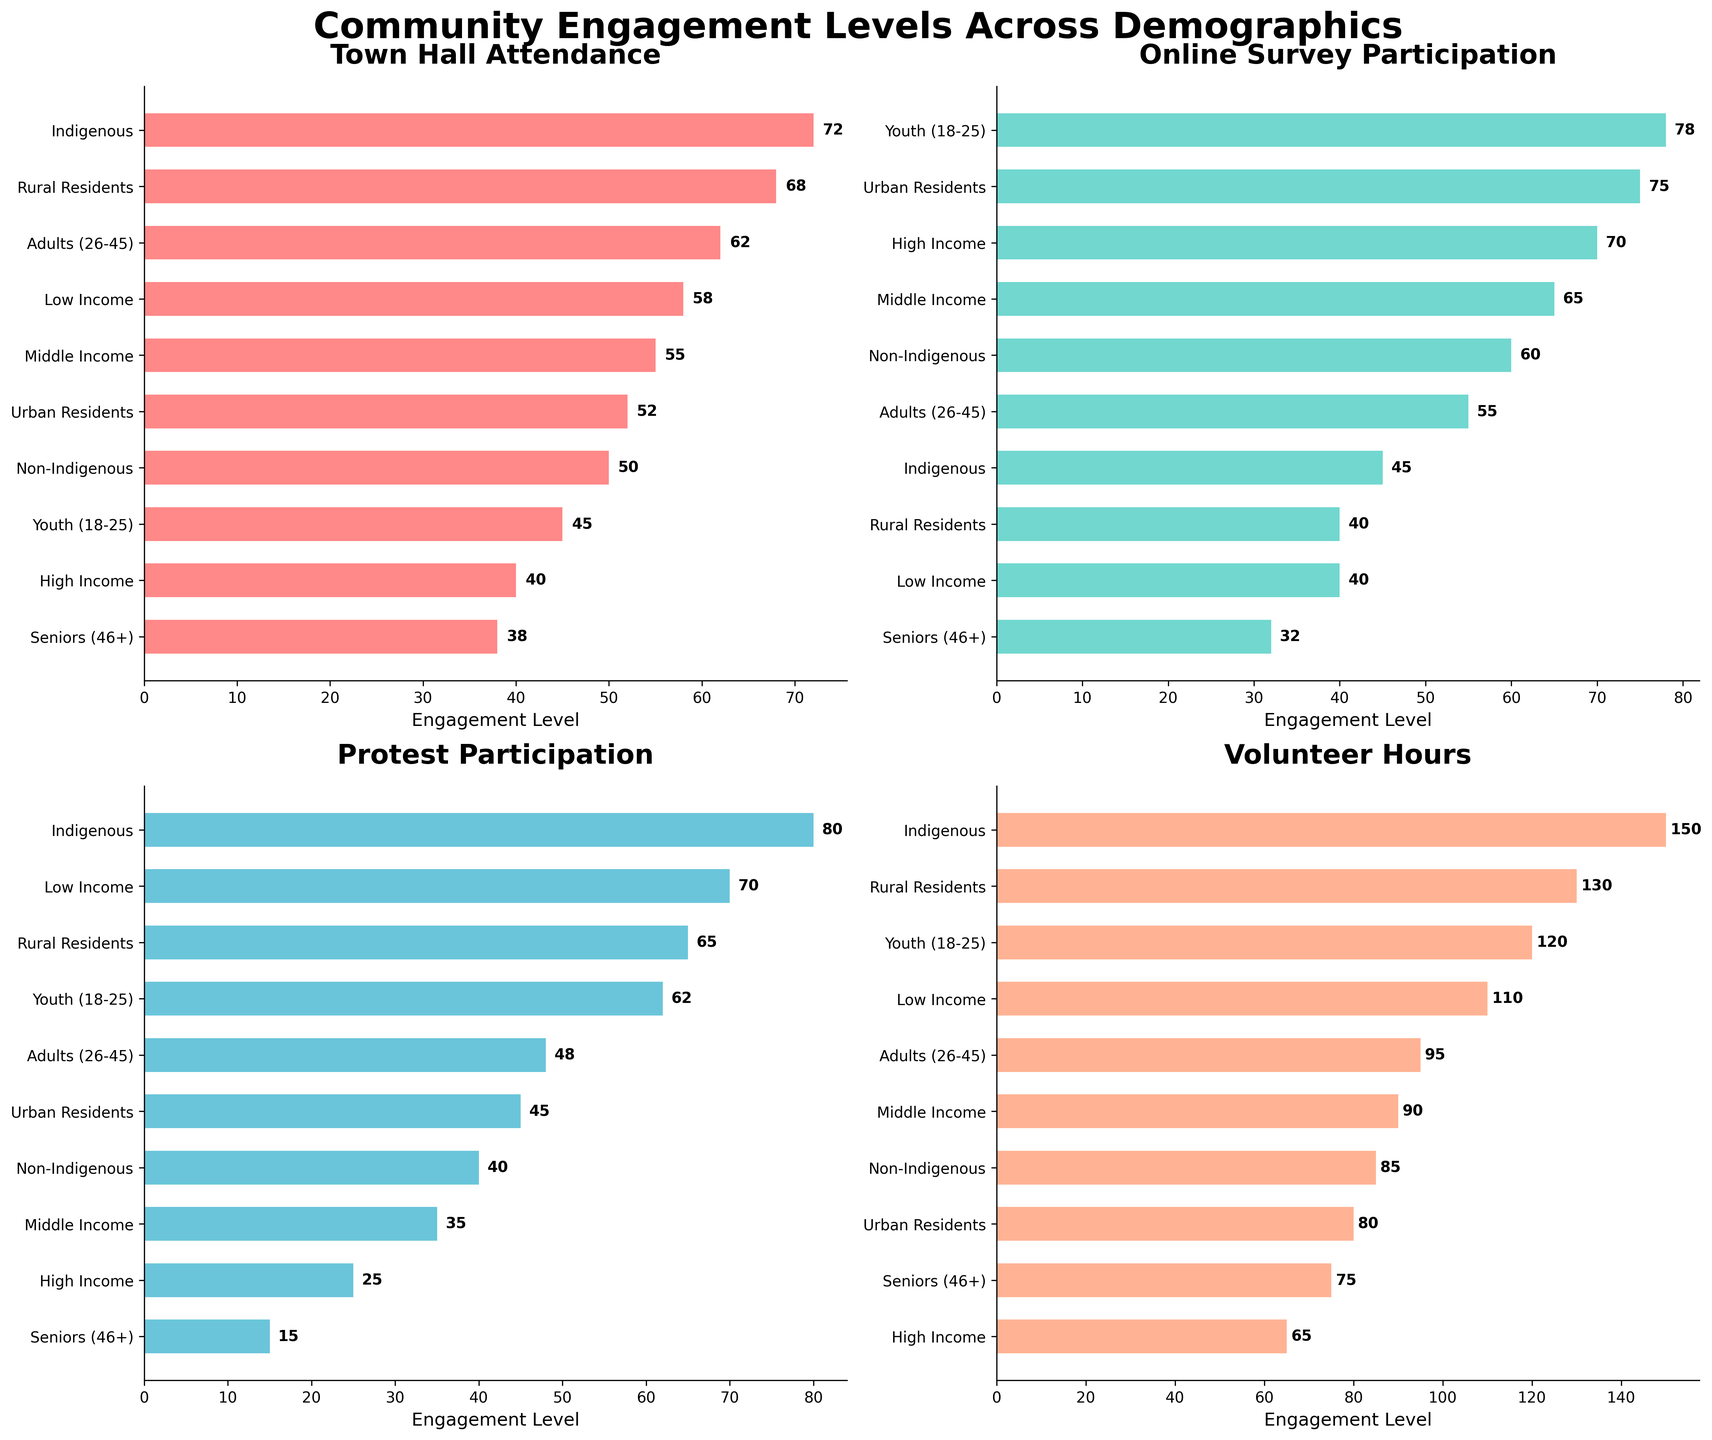What demographic has the highest town hall attendance? Look at the subplot titled "Town Hall Attendance" and identify the top bar. The top bar represents the "Indigenous" demographic with the highest town hall attendance value of 72.
Answer: Indigenous Which demographic participated least in protests? Observe the "Protest Participation" subplot and find the bar with the lowest value. The shortest bar corresponds to the "Seniors (46+)" demographic with a value of 15.
Answer: Seniors (46+) How many different demographics are presented in each subplot? Each subplot represents the same set of demographics. Count the number of bars in any subplot, which should be consistent across all subplots. There are 10 bars representing 10 different demographics.
Answer: 10 What is the average town hall attendance of Urban and Rural residents? Identify the "Town Hall Attendance" values for Urban (52) and Rural (68). Sum the values and divide by 2 to get the average: (52 + 68) / 2 = 60.
Answer: 60 Which demographic volunteers the most hours? Look at the "Volunteer Hours" subplot and identify the top bar. The demographic with the highest value, 150 hours, is "Indigenous".
Answer: Indigenous Compare the Online Survey Participation between Low Income and High Income demographics. Which has higher participation and by how much? Find the "Online Survey Participation" values for Low Income (40) and High Income (70). Subtract the smaller value from the larger value: 70 - 40 = 30. High Income participates more by 30 units.
Answer: High Income by 30 Which demographic has the lowest engagement in online surveys? In the "Online Survey Participation" subplot, identify the shortest bar. The "Seniors (46+)" demographic shows the lowest value at 32.
Answer: Seniors (46+) Between adults (26-45) and seniors (46+), who has higher protest participation and what is the difference? Determine the protest participation values for Adults (48) and Seniors (15). Subtract the smaller value from the larger: 48 - 15 = 33. Adults have higher participation by 33 units.
Answer: Adults by 33 What is the total volunteer hours contributed by Youth and Seniors? Find the volunteer hours values for Youth (120) and Seniors (75) and sum them: 120 + 75 = 195.
Answer: 195 Identify two demographics that have similar levels of Online Survey Participation and specify the value. Check the "Online Survey Participation" subplot for any similar bar lengths. Both Middle Income (65) and Non-Indigenous (60) have close values.
Answer: Middle Income (65) and Non-Indigenous (60) 